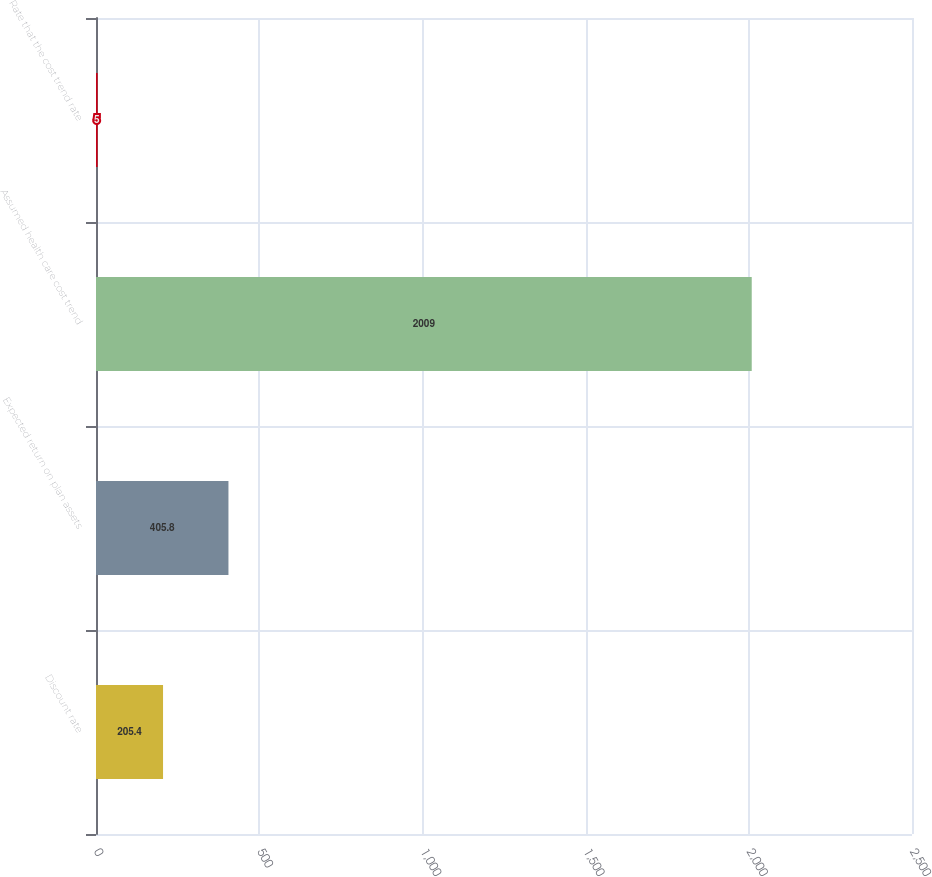Convert chart. <chart><loc_0><loc_0><loc_500><loc_500><bar_chart><fcel>Discount rate<fcel>Expected return on plan assets<fcel>Assumed health care cost trend<fcel>Rate that the cost trend rate<nl><fcel>205.4<fcel>405.8<fcel>2009<fcel>5<nl></chart> 